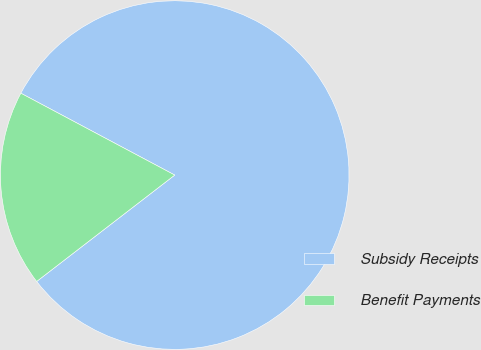Convert chart. <chart><loc_0><loc_0><loc_500><loc_500><pie_chart><fcel>Subsidy Receipts<fcel>Benefit Payments<nl><fcel>81.77%<fcel>18.23%<nl></chart> 